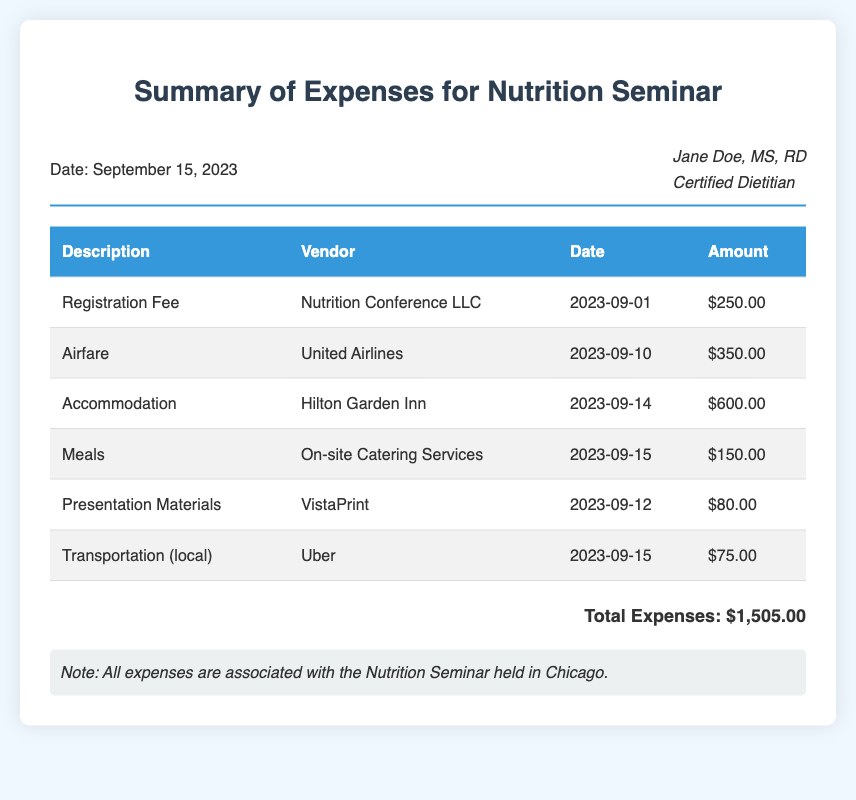What is the date of the seminar? The date of the seminar is provided in the header section of the document.
Answer: September 15, 2023 Who is the attendee listed in the bill? The attendee's name along with their credentials is included in the header section.
Answer: Jane Doe, MS, RD What was the amount for the airfare? The airfare cost is specified in the table under the corresponding category.
Answer: $350.00 How much did the accommodation cost? The cost for accommodation can be found in the designated row in the expense table.
Answer: $600.00 What was the total amount of expenses? The total expenses are calculated and presented at the bottom of the document.
Answer: $1,505.00 What vendor provided the presentation materials? The vendor for the presentation materials is indicated in the table next to the related expense.
Answer: VistaPrint What is the expense of the meals? The meals' expense is listed in the relevant row in the table.
Answer: $150.00 What type of document is this? The title of the document indicates the purpose and content of the document.
Answer: Summary of Expenses for Nutrition Seminar 